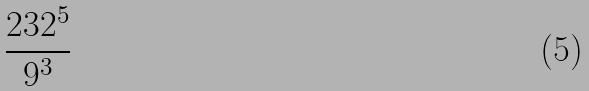<formula> <loc_0><loc_0><loc_500><loc_500>\frac { 2 3 2 ^ { 5 } } { 9 ^ { 3 } }</formula> 